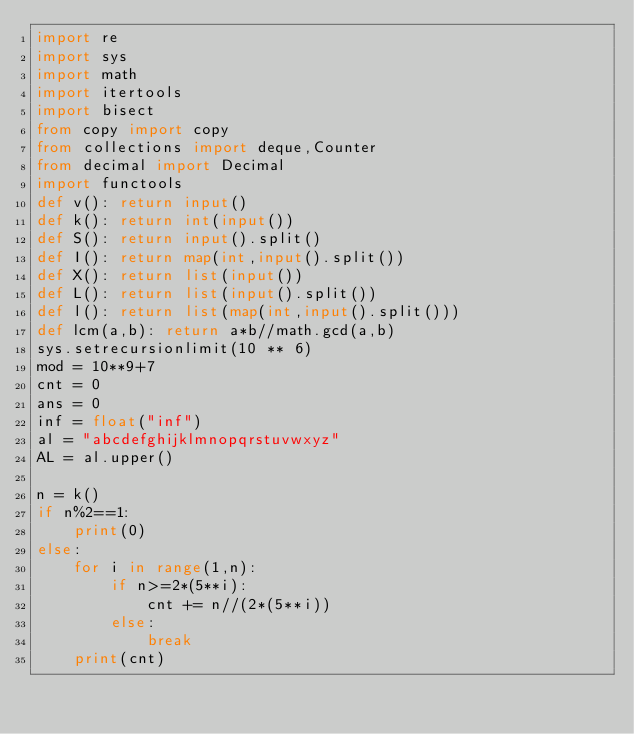Convert code to text. <code><loc_0><loc_0><loc_500><loc_500><_Python_>import re
import sys
import math
import itertools
import bisect
from copy import copy
from collections import deque,Counter
from decimal import Decimal
import functools
def v(): return input()
def k(): return int(input())
def S(): return input().split()
def I(): return map(int,input().split())
def X(): return list(input())
def L(): return list(input().split())
def l(): return list(map(int,input().split()))
def lcm(a,b): return a*b//math.gcd(a,b)
sys.setrecursionlimit(10 ** 6)
mod = 10**9+7
cnt = 0
ans = 0
inf = float("inf")
al = "abcdefghijklmnopqrstuvwxyz"
AL = al.upper()

n = k()
if n%2==1:
    print(0)
else:
    for i in range(1,n):
        if n>=2*(5**i):
            cnt += n//(2*(5**i))
        else:
            break
    print(cnt)</code> 